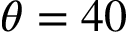Convert formula to latex. <formula><loc_0><loc_0><loc_500><loc_500>\theta = 4 0</formula> 